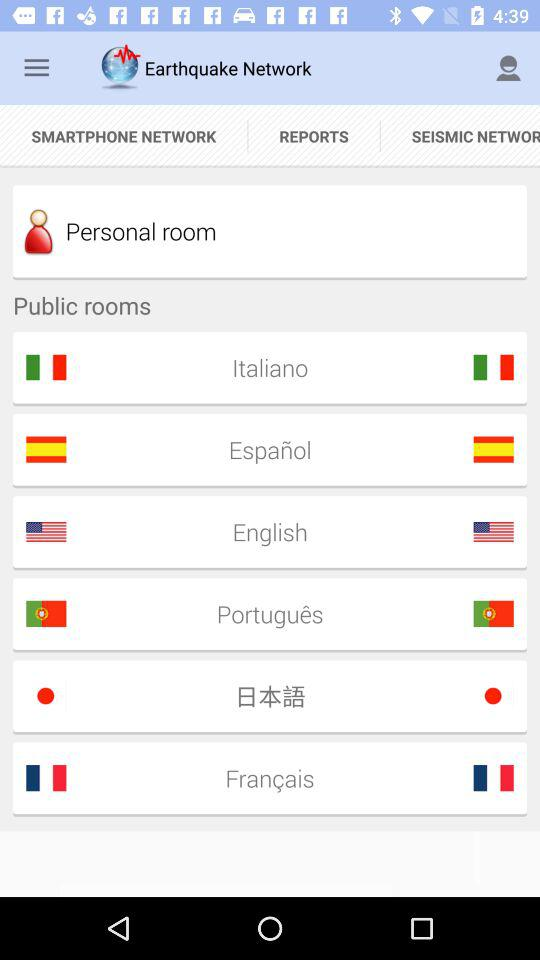What is the application name? The application name is "Earthquake Network". 